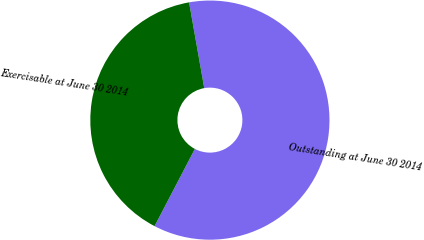<chart> <loc_0><loc_0><loc_500><loc_500><pie_chart><fcel>Outstanding at June 30 2014<fcel>Exercisable at June 30 2014<nl><fcel>60.44%<fcel>39.56%<nl></chart> 